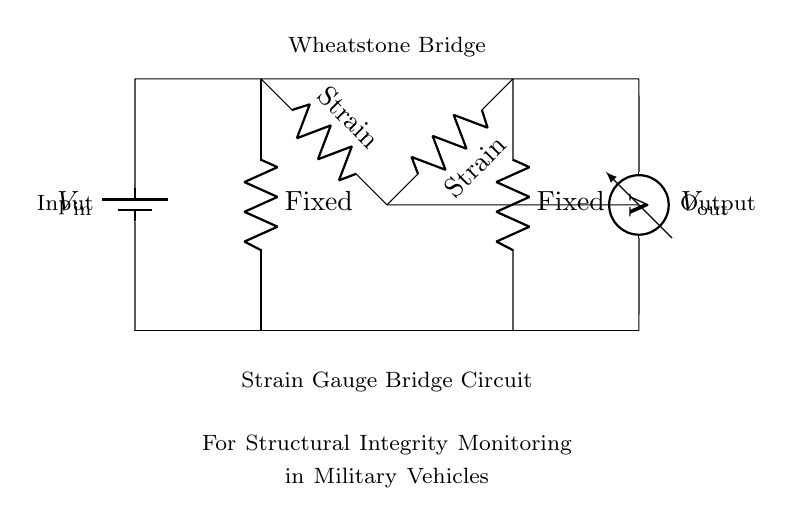What is the input voltage symbol in the circuit? The input voltage in the circuit is represented by the battery symbol labeled as V_in, indicating where the voltage is applied to the Wheatstone Bridge.
Answer: V_in What are the values of the fixed resistors? The fixed resistors in the bridge circuit are labeled R_1 and R_3, but their specific numerical values are not provided in the diagram. However, they are defined as fixed resistors.
Answer: R_1 and R_3 How many strain gauges are used in this circuit? The circuit includes two strain gauges, which are represented by resistors labeled R_2 and R_4.
Answer: Two What does the output voltage measure? The output voltage, labeled as V_out, measures the voltage difference across the two strain gauges in the Wheatstone Bridge configuration, indicating changes due to strain.
Answer: Voltage difference Which component of the circuit is responsible for measuring structural integrity? The strain gauges (R_2 and R_4) are responsible for measuring structural integrity by responding to deformation in the military vehicle, changing their resistance and affecting the output voltage.
Answer: Strain gauges What type of circuit is this? This circuit is a Wheatstone Bridge, which is specifically designed to measure resistance changes due to strain in the materials it monitors.
Answer: Wheatstone Bridge What happens to V_out if there is significant strain detected? If significant strain is detected, the resistances of R_2 and R_4 will change, resulting in a different voltage output (V_out) based on the changes, which indicates the amount of strain experienced.
Answer: Changes in output voltage 